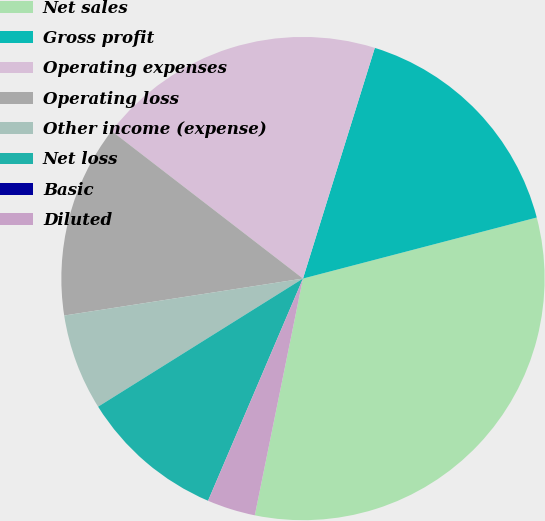<chart> <loc_0><loc_0><loc_500><loc_500><pie_chart><fcel>Net sales<fcel>Gross profit<fcel>Operating expenses<fcel>Operating loss<fcel>Other income (expense)<fcel>Net loss<fcel>Basic<fcel>Diluted<nl><fcel>32.26%<fcel>16.13%<fcel>19.35%<fcel>12.9%<fcel>6.45%<fcel>9.68%<fcel>0.0%<fcel>3.23%<nl></chart> 